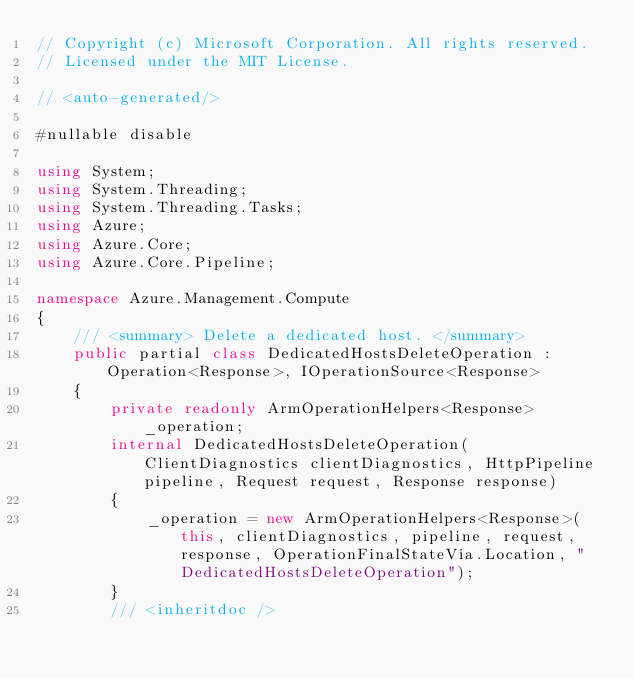Convert code to text. <code><loc_0><loc_0><loc_500><loc_500><_C#_>// Copyright (c) Microsoft Corporation. All rights reserved.
// Licensed under the MIT License.

// <auto-generated/>

#nullable disable

using System;
using System.Threading;
using System.Threading.Tasks;
using Azure;
using Azure.Core;
using Azure.Core.Pipeline;

namespace Azure.Management.Compute
{
    /// <summary> Delete a dedicated host. </summary>
    public partial class DedicatedHostsDeleteOperation : Operation<Response>, IOperationSource<Response>
    {
        private readonly ArmOperationHelpers<Response> _operation;
        internal DedicatedHostsDeleteOperation(ClientDiagnostics clientDiagnostics, HttpPipeline pipeline, Request request, Response response)
        {
            _operation = new ArmOperationHelpers<Response>(this, clientDiagnostics, pipeline, request, response, OperationFinalStateVia.Location, "DedicatedHostsDeleteOperation");
        }
        /// <inheritdoc /></code> 